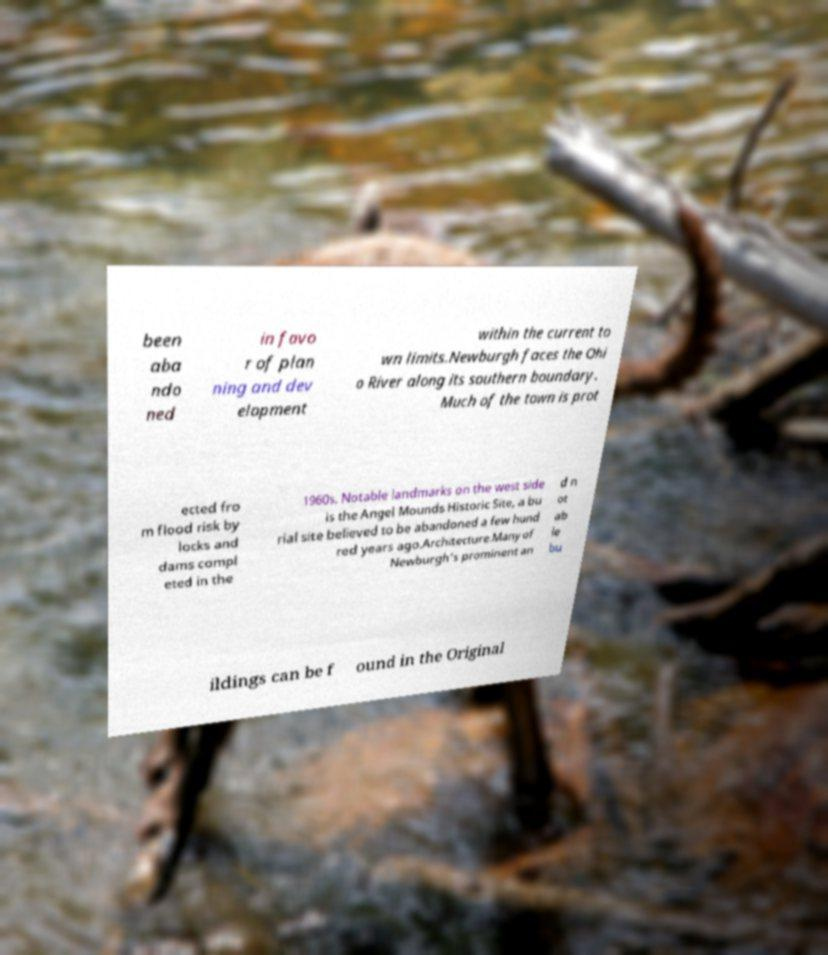Could you assist in decoding the text presented in this image and type it out clearly? been aba ndo ned in favo r of plan ning and dev elopment within the current to wn limits.Newburgh faces the Ohi o River along its southern boundary. Much of the town is prot ected fro m flood risk by locks and dams compl eted in the 1960s. Notable landmarks on the west side is the Angel Mounds Historic Site, a bu rial site believed to be abandoned a few hund red years ago.Architecture.Many of Newburgh's prominent an d n ot ab le bu ildings can be f ound in the Original 